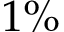<formula> <loc_0><loc_0><loc_500><loc_500>1 \%</formula> 